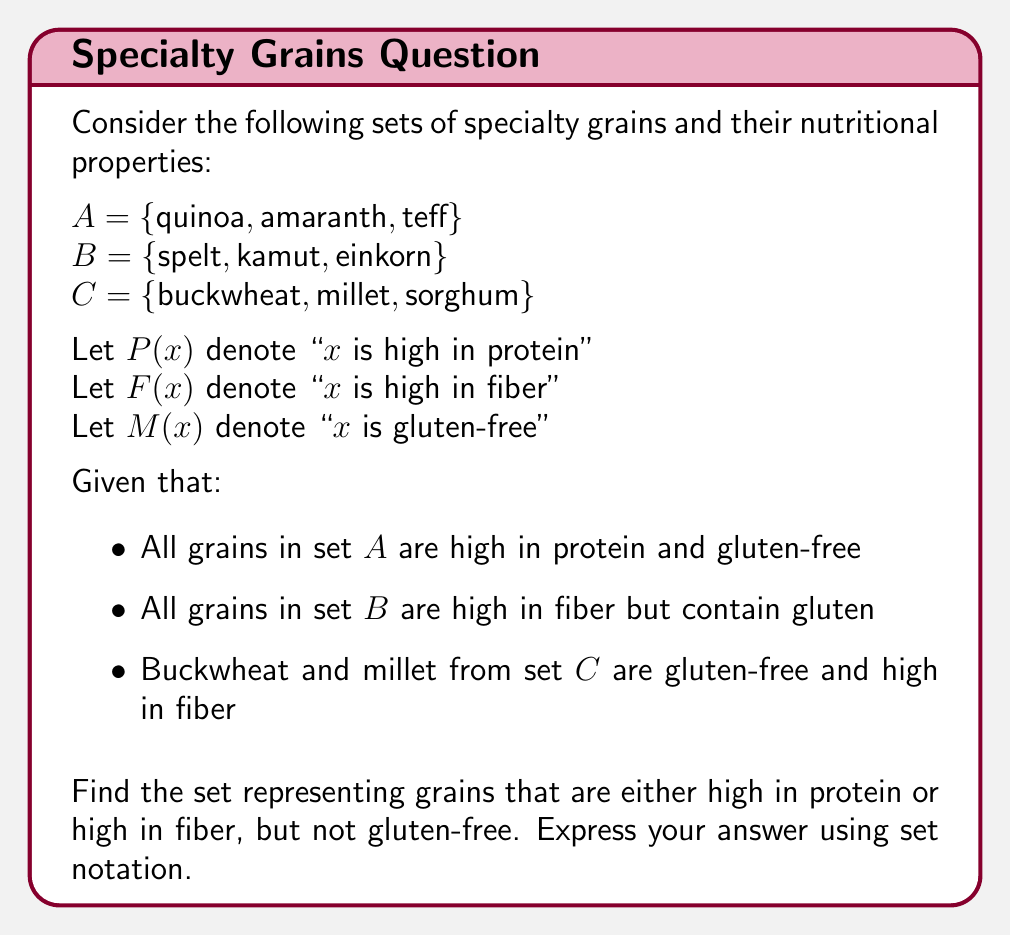Show me your answer to this math problem. Let's approach this step-by-step using set theory:

1) First, let's define our universal set U as the union of all given sets:
   $U = A \cup B \cup C$

2) Now, let's define sets based on the given properties:
   $P = \{x \in U : P(x)\} = A = \{quinoa, amaranth, teff\}$
   $F = \{x \in U : F(x)\} = B \cup \{buckwheat, millet\}$
   $M = \{x \in U : M(x)\} = A \cup \{buckwheat, millet\}$

3) The question asks for grains that are either high in protein or high in fiber:
   $P \cup F$

4) But we need to exclude the gluten-free grains from this set:
   $(P \cup F) \setminus M$

5) Let's evaluate this step-by-step:
   $P \cup F = A \cup B \cup \{buckwheat, millet\}$
   $= \{quinoa, amaranth, teff, spelt, kamut, einkorn, buckwheat, millet\}$

6) Now, let's subtract M:
   $(P \cup F) \setminus M = \{spelt, kamut, einkorn\}$

This result makes sense because:
- Spelt, kamut, and einkorn are high in fiber (part of set B)
- They are not gluten-free (not part of set M)
- They satisfy the condition of being high in fiber but not gluten-free
Answer: $\{spelt, kamut, einkorn\}$ 